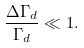Convert formula to latex. <formula><loc_0><loc_0><loc_500><loc_500>\frac { \Delta \Gamma _ { d } } { \Gamma _ { d } } \ll 1 .</formula> 